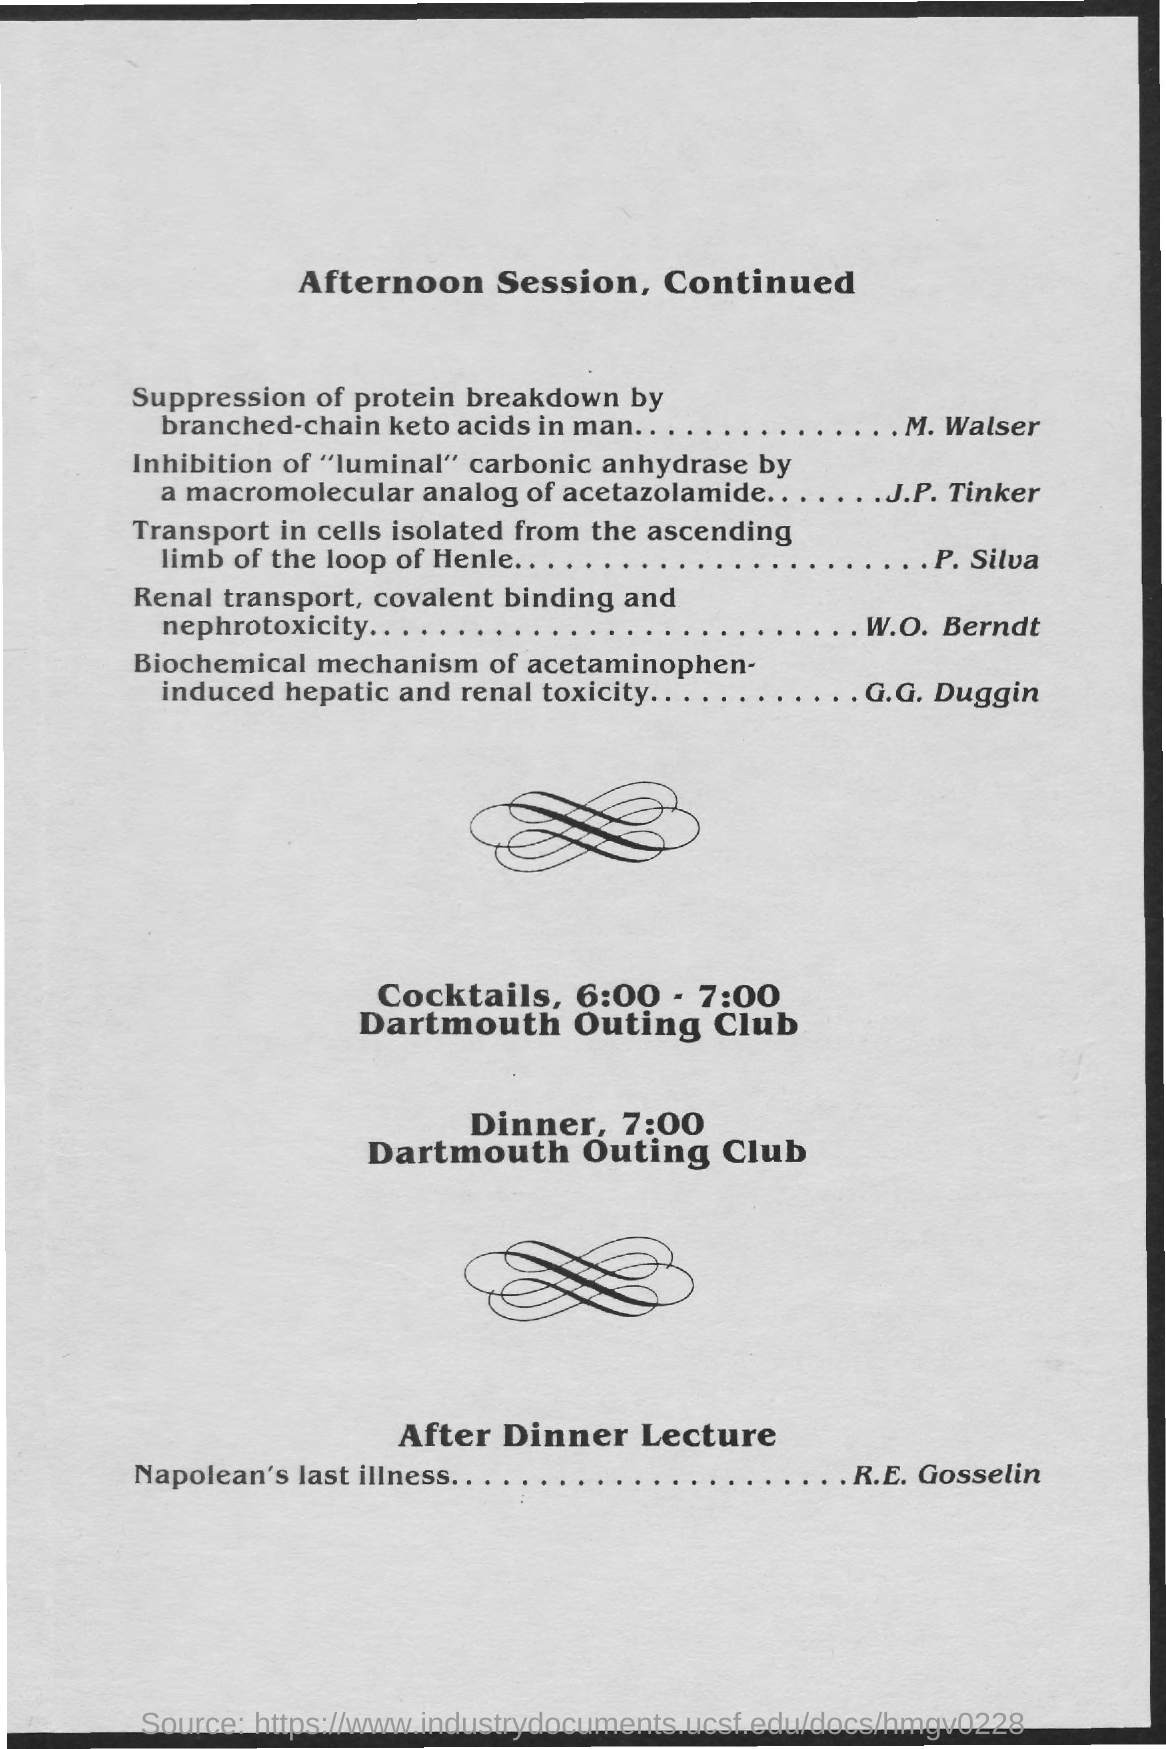Give some essential details in this illustration. The venue for dinner is the Dartmouth Outing Club. At 7:00 PM, the time has been mentioned for dinner. The after dinner lecture is a presentation given after a meal, often discussing historical events such as Napoleon's last illness. 